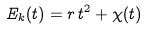<formula> <loc_0><loc_0><loc_500><loc_500>E _ { k } ( t ) = r \, t ^ { 2 } + \chi ( t )</formula> 